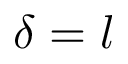Convert formula to latex. <formula><loc_0><loc_0><loc_500><loc_500>\delta = l</formula> 